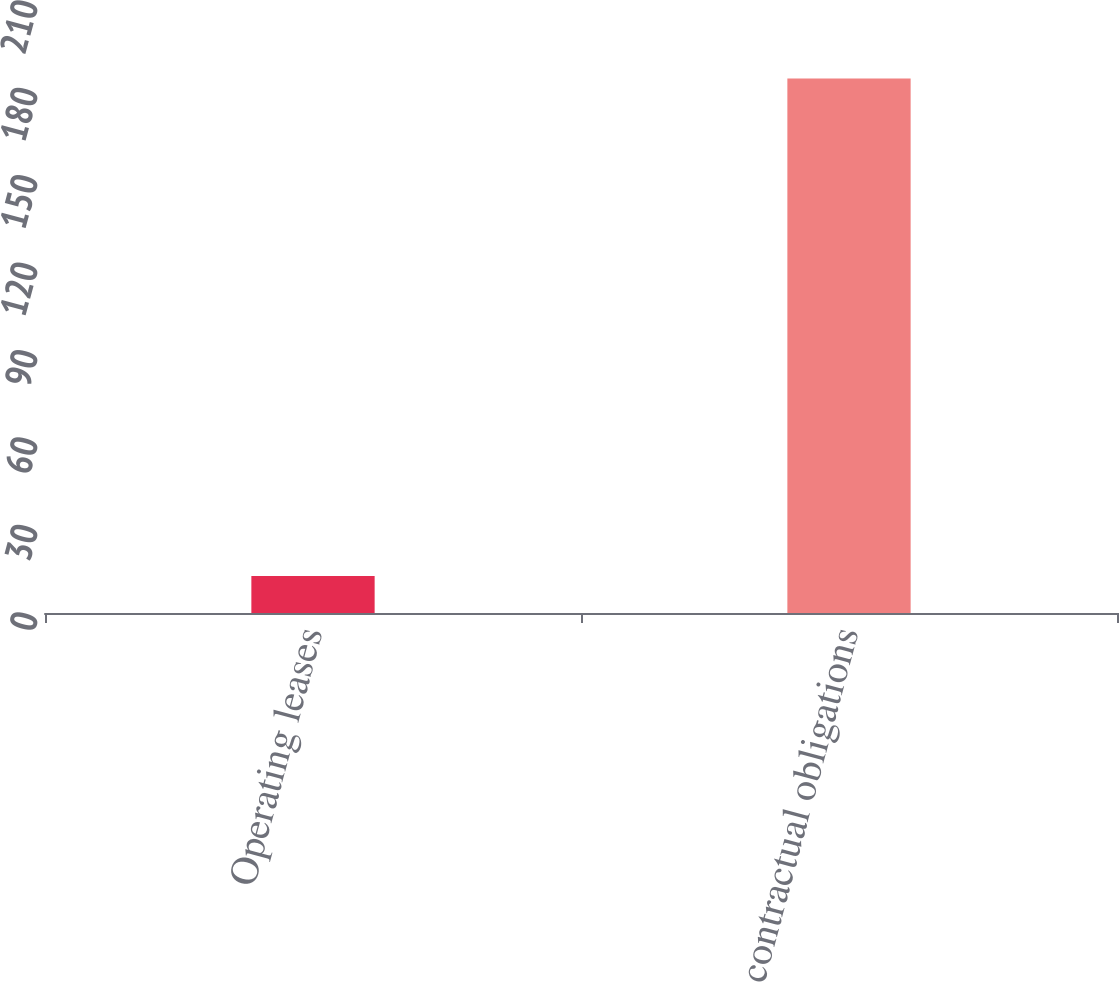Convert chart to OTSL. <chart><loc_0><loc_0><loc_500><loc_500><bar_chart><fcel>Operating leases<fcel>Total contractual obligations<nl><fcel>12.7<fcel>183.4<nl></chart> 